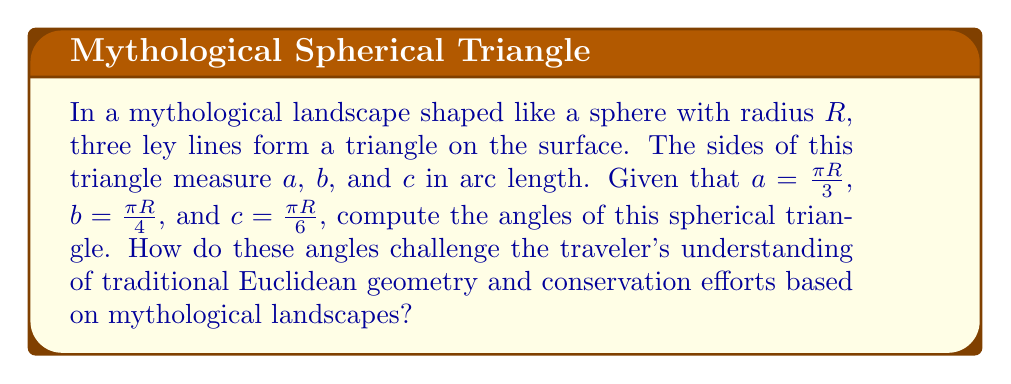What is the answer to this math problem? To solve this problem, we'll use the spherical law of cosines and follow these steps:

1) The spherical law of cosines states:
   $$\cos(c) = \cos(a)\cos(b) + \sin(a)\sin(b)\cos(C)$$
   where $C$ is the angle opposite side $c$.

2) We can rearrange this to solve for $\cos(C)$:
   $$\cos(C) = \frac{\cos(c) - \cos(a)\cos(b)}{\sin(a)\sin(b)}$$

3) Let's calculate $\cos(a)$, $\cos(b)$, $\cos(c)$, $\sin(a)$, and $\sin(b)$:
   $$\cos(a) = \cos(\frac{\pi}{3}) = \frac{1}{2}$$
   $$\cos(b) = \cos(\frac{\pi}{4}) = \frac{\sqrt{2}}{2}$$
   $$\cos(c) = \cos(\frac{\pi}{6}) = \frac{\sqrt{3}}{2}$$
   $$\sin(a) = \sin(\frac{\pi}{3}) = \frac{\sqrt{3}}{2}$$
   $$\sin(b) = \sin(\frac{\pi}{4}) = \frac{\sqrt{2}}{2}$$

4) Now we can substitute these values into our equation:
   $$\cos(C) = \frac{\frac{\sqrt{3}}{2} - \frac{1}{2} \cdot \frac{\sqrt{2}}{2}}{\frac{\sqrt{3}}{2} \cdot \frac{\sqrt{2}}{2}}$$

5) Simplifying:
   $$\cos(C) = \frac{\sqrt{6} - 1}{\sqrt{3}}$$

6) We can find $C$ by taking the arccos of both sides:
   $$C = \arccos(\frac{\sqrt{6} - 1}{\sqrt{3}}) \approx 0.873 \text{ radians} \approx 50.0°$$

7) We can repeat this process for angles A and B:
   $$A = \arccos(\frac{\sqrt{6} + 1}{\sqrt{3}}) \approx 0.955 \text{ radians} \approx 54.7°$$
   $$B = \arccos(\frac{3 - \sqrt{6}}{\sqrt{3}}) \approx 1.314 \text{ radians} \approx 75.3°$$

8) The sum of these angles is approximately 180°, which challenges the traveler's Euclidean understanding. In spherical geometry, the sum of angles in a triangle is always greater than 180°.
Answer: $A \approx 54.7°$, $B \approx 75.3°$, $C \approx 50.0°$; sum $\approx 180°$ 